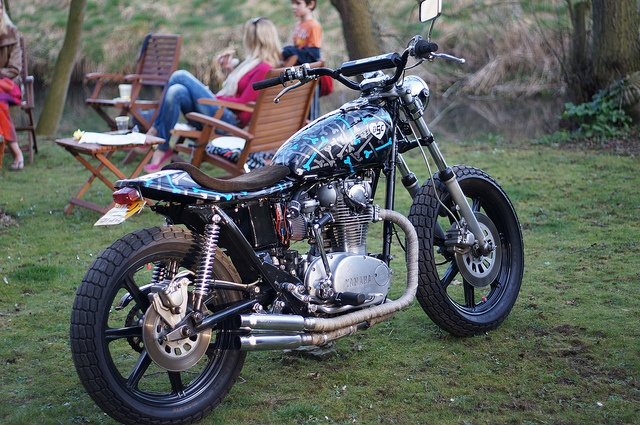Describe the objects in this image and their specific colors. I can see motorcycle in gray, black, navy, and lightgray tones, chair in gray, brown, maroon, and black tones, people in gray, darkgray, lightgray, blue, and navy tones, chair in gray, brown, and black tones, and dining table in gray, white, brown, and maroon tones in this image. 